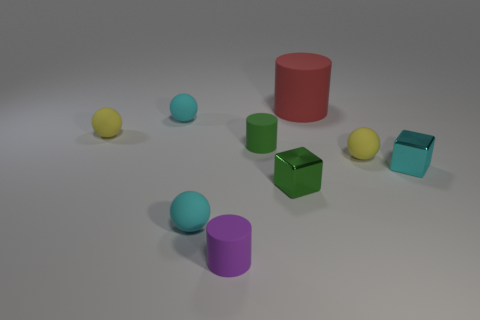Subtract all red balls. Subtract all red cylinders. How many balls are left? 4 Add 1 large red cylinders. How many objects exist? 10 Subtract all blocks. How many objects are left? 7 Add 4 green metallic things. How many green metallic things are left? 5 Add 2 small spheres. How many small spheres exist? 6 Subtract 0 blue cylinders. How many objects are left? 9 Subtract all cyan things. Subtract all big cylinders. How many objects are left? 5 